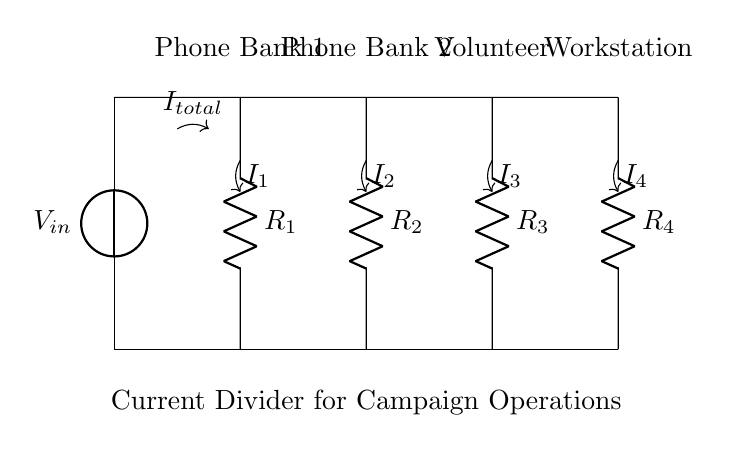What is the total current entering the circuit? The total current entering the circuit is represented by the symbol I_total, which shows that all the current sourced from the voltage source enters the upper node before splitting into the various branches.
Answer: I_total What are the resistances in the circuit? The circuit has four resistances, labeled as R1, R2, R3, and R4. These resistors are arranged in parallel and each has an impact on the current flowing through them.
Answer: R1, R2, R3, R4 Which phone bank receives the highest current? To determine which phone bank receives the highest current, you would analyze the resistances: the lower the resistance, the more current it receives according to Ohm's law. Since no specific resistances are given, if all resistances are equal, they would receive equal current.
Answer: Equal current (if resistances are equal) How is the total voltage in the circuit defined? The total voltage in the circuit is defined by the voltage source V_in, which provides the potential difference necessary for current to flow. This voltage is distributed across the parallel branches of the circuit.
Answer: V_in What happens to the currents through resistors if R2 is halved? If R2 is halved, the current through that resistor increases because current is inversely proportional to resistance in parallel circuits. Therefore, the other branches will see a decrease in current.
Answer: Current through R2 increases What is the role of the current divider in this circuit? The role of the current divider is to distribute the total current I_total among the different branches (phone banks and the workstation) based on their resistances. This allows for efficient use of the current for powering multiple components.
Answer: Distributes current based on resistances 